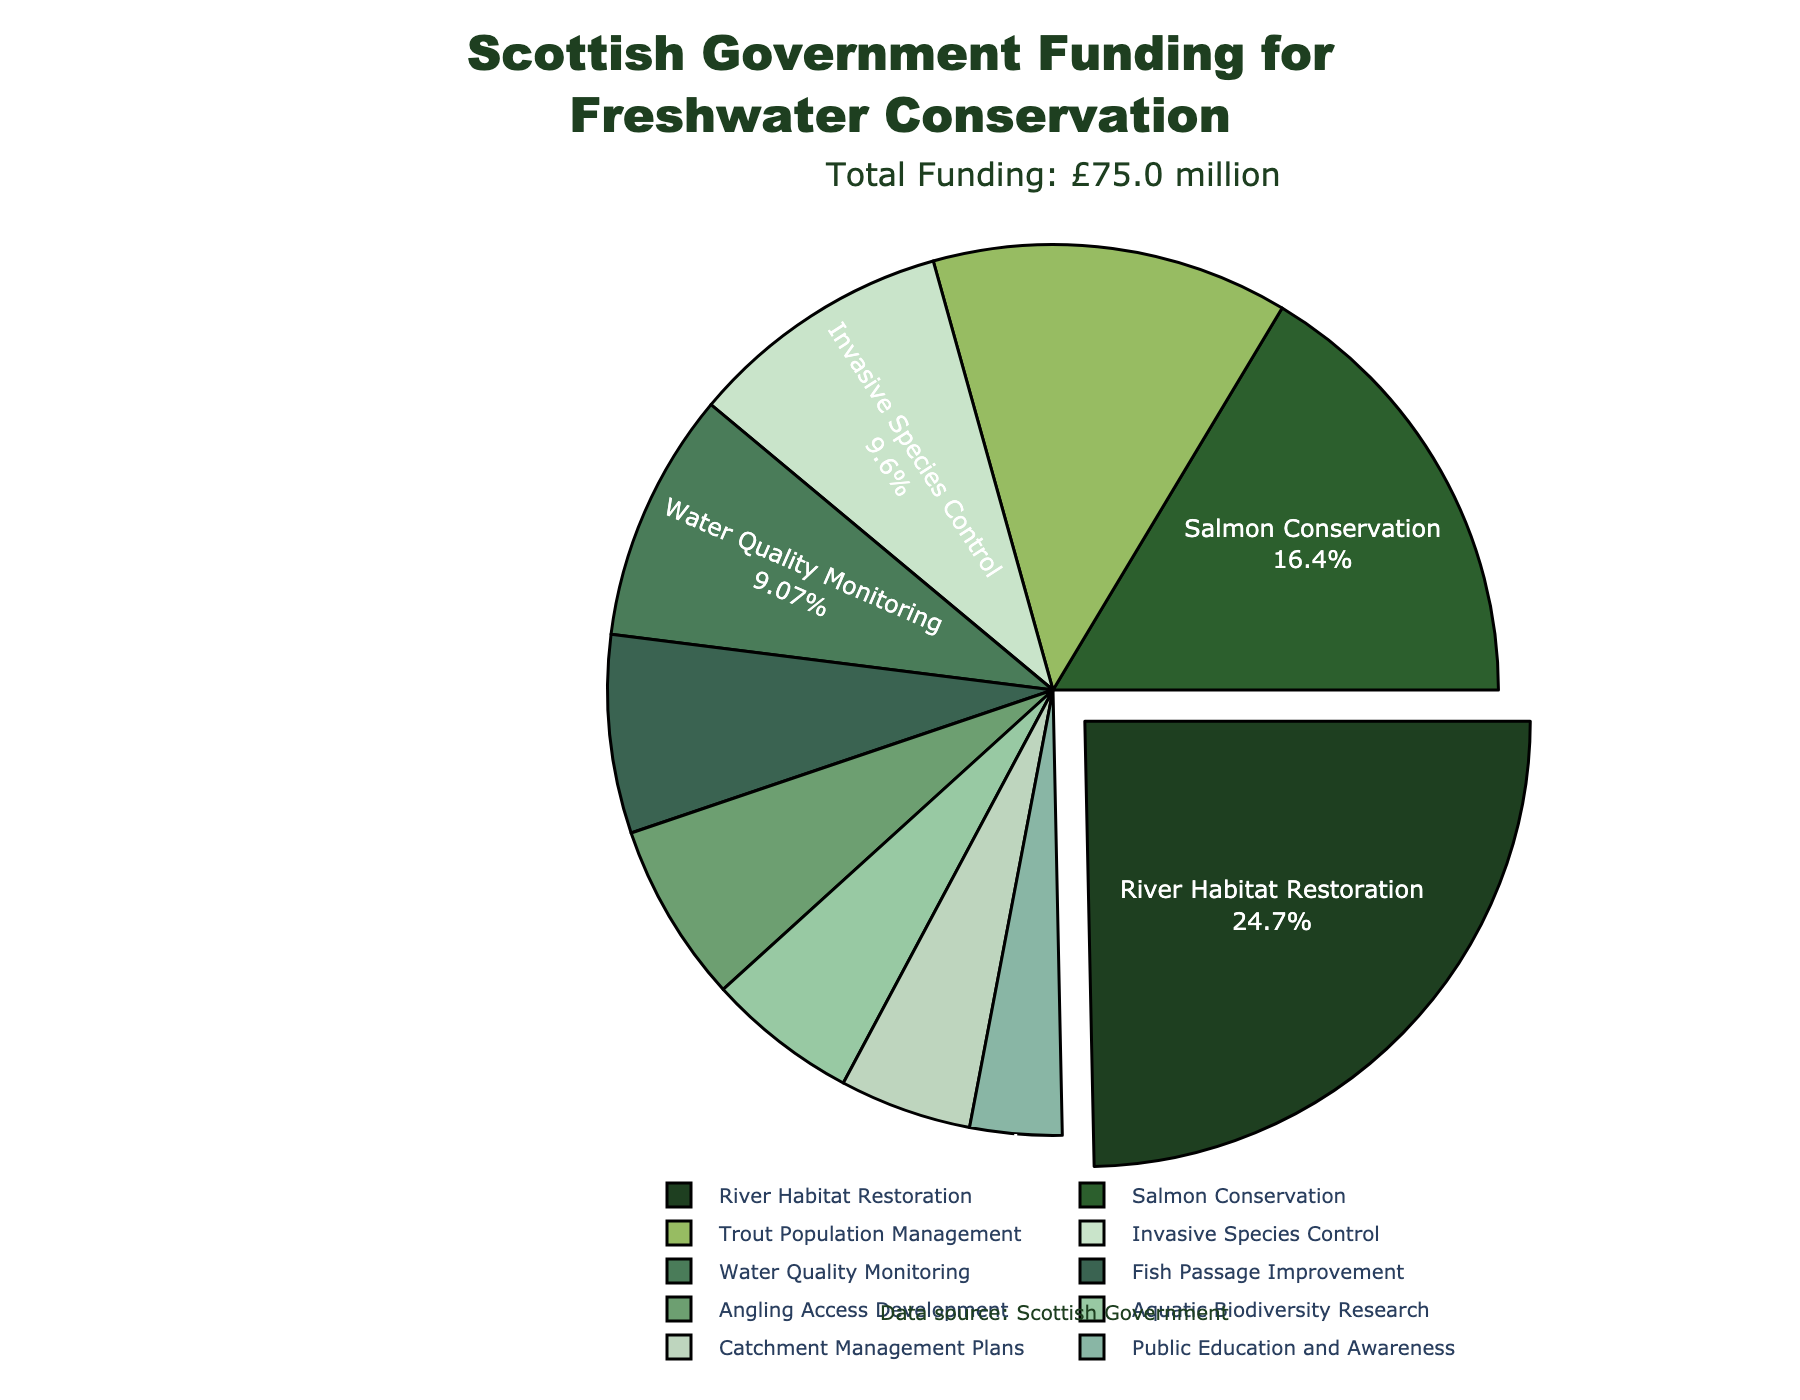What's the largest funding category for freshwater conservation efforts in Scotland? The largest funding category can be identified by finding the category with the highest value. The 'River Habitat Restoration' category has the largest allocation at £18.5 million.
Answer: River Habitat Restoration Which funding category received the least allocation? To determine the smallest category, we look for the item with the smallest value. The category 'Public Education and Awareness' received the least allocation at £2.5 million.
Answer: Public Education and Awareness How much more funding is allocated to 'River Habitat Restoration' compared to 'Angling Access Development'? First, identify the funding for both categories: £18.5 million for 'River Habitat Restoration' and £4.9 million for 'Angling Access Development'. Subtract the smaller value from the larger value: £18.5 million - £4.9 million = £13.6 million.
Answer: £13.6 million What percentage of the total funding is allocated to 'Salmon Conservation' and 'Trout Population Management' combined? Calculate the combined funding of both categories (£12.3 million + £9.7 million) which equals £22 million. Find the total funding by summing all categories (£75 million). Then, calculate the percentage: (22 / 75) * 100 = 29.3%.
Answer: 29.3% Which category is represented by the greenest shade in the pie chart? The greenest shade in the pie chart, which is closer to dark green, is assigned to 'River Habitat Restoration'.
Answer: River Habitat Restoration Is the 'Fish Passage Improvement' funding greater than the 'Water Quality Monitoring' funding? Compare the two values: 'Fish Passage Improvement' is £5.4 million and 'Water Quality Monitoring' is £6.8 million. Since £5.4 million < £6.8 million, Fish Passage Improvement is not greater.
Answer: No How much total funding is allocated to categories related to fish (Salmon Conservation, Trout Population Management, Fish Passage Improvement)? Sum the funding for the related categories: £12.3 million (Salmon Conservation) + £9.7 million (Trout Population Management) + £5.4 million (Fish Passage Improvement) = £27.4 million.
Answer: £27.4 million Which funding category is represented by the smallest slice of the pie chart, and what is its allocation? The category with the smallest slice in the chart refers to 'Public Education and Awareness', which has an allocation of £2.5 million.
Answer: Public Education and Awareness, £2.5 million 